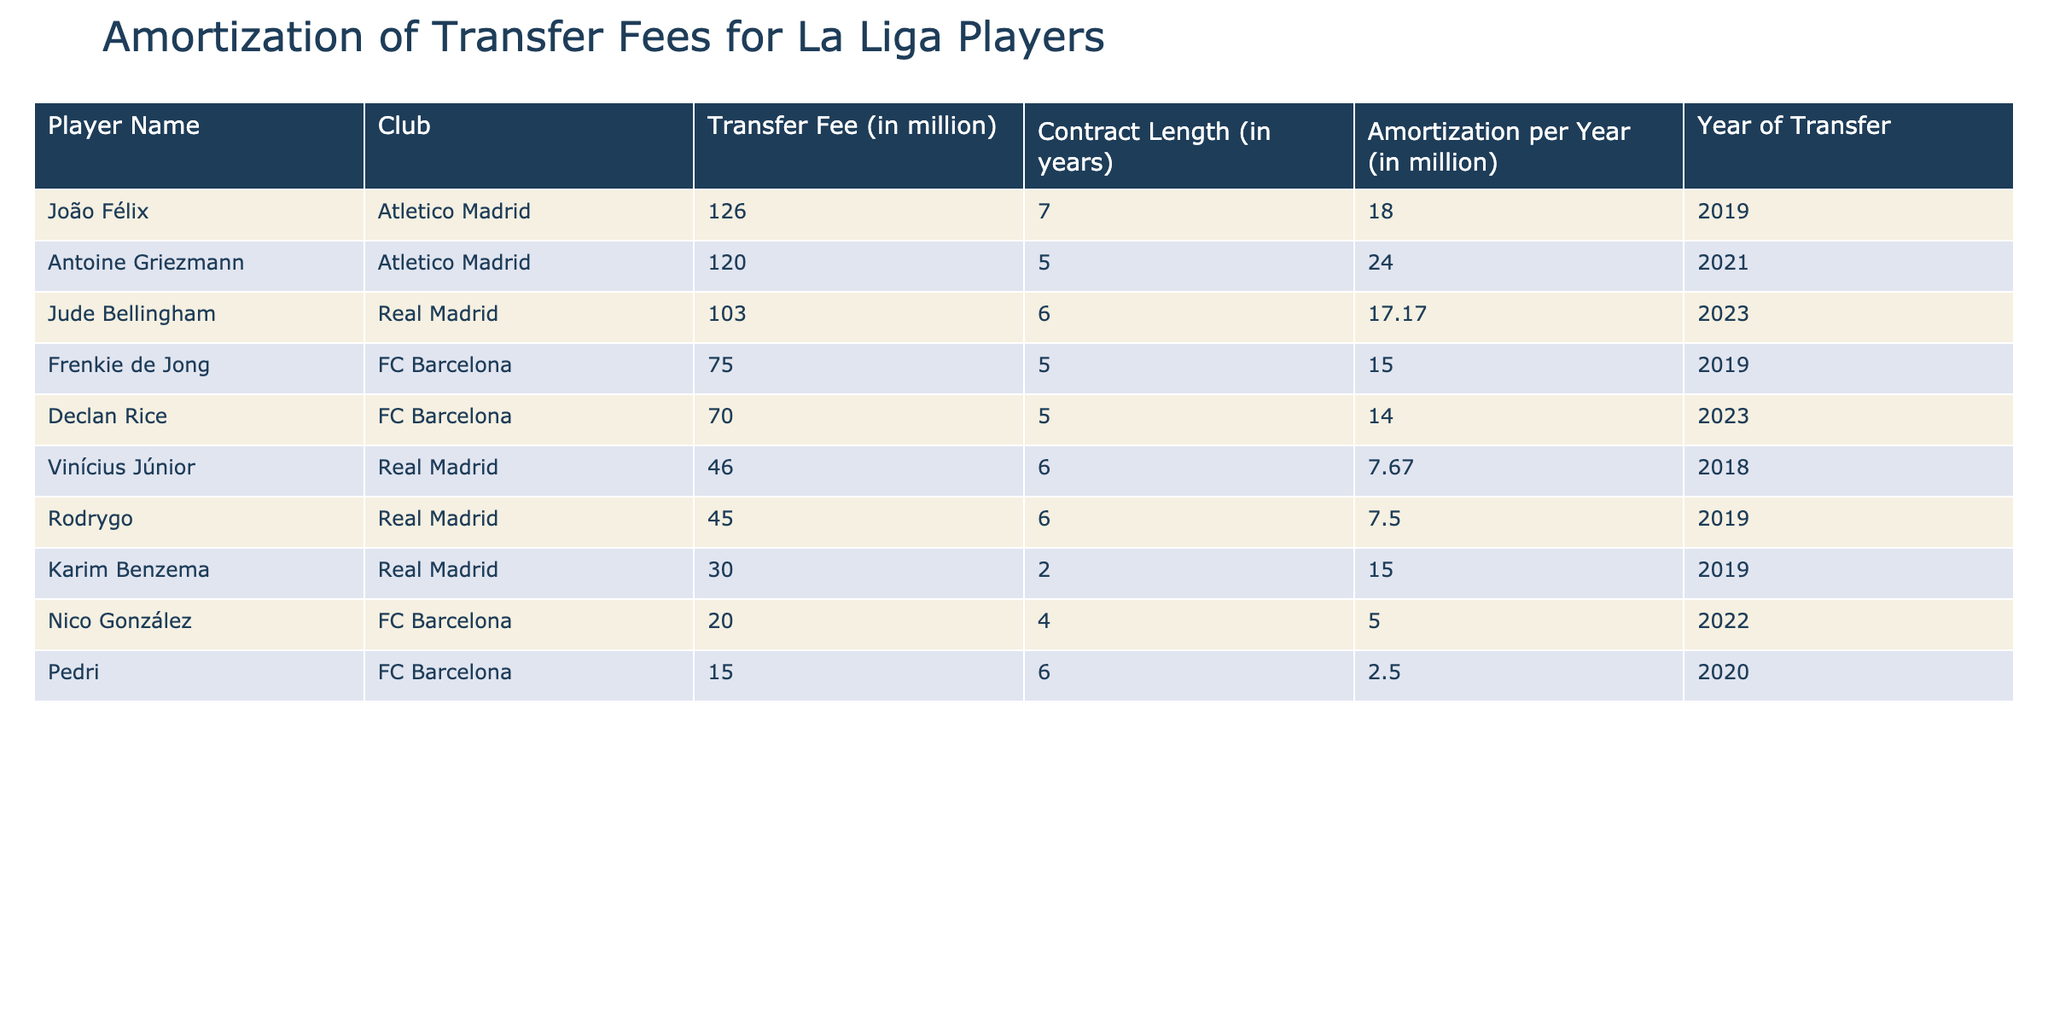What is the highest transfer fee recorded in the table? By looking at the 'Transfer Fee (in million)' column, we can see that the highest fee is associated with Antoine Griezmann, where the fee is 120 million.
Answer: 120 million Which player has the longest contract length? The 'Contract Length (in years)' column shows that João Félix has a contract length of 7 years, which is the longest compared to other players in the table.
Answer: 7 years What is the total amortization amount for players from Real Madrid? We need to sum the 'Amortization per Year (in million)' values for players like Jude Bellingham, Rodrygo, and Vinícius Júnior. The total is 17.17 + 7.50 + 7.67 = 32.34 million.
Answer: 32.34 million Is the amortization per year for Declan Rice higher than that for Frenkie de Jong? By comparing the 'Amortization per Year (in million)' values, Declan Rice has 14.00 million and Frenkie de Jong has 15.00 million. Declan Rice's amortization is lower.
Answer: No What is the average amortization for players in FC Barcelona? To find the average, we will look at the players from FC Barcelona: Declan Rice (14.00), Frenkie de Jong (15.00), Pedri (2.50), and Nico González (5.00). The total is 36.50 million, and there are 4 players, so the average is 36.50 / 4 = 9.125 million.
Answer: 9.125 million Who has a lower transfer fee, Rodrygo or Vinícius Júnior? Checking the 'Transfer Fee (in million)' for both players, Rodrygo has a fee of 45 million while Vinícius Júnior has a fee of 46 million. Therefore, Rodrygo has the lower transfer fee.
Answer: Rodrygo What is the difference in amortization between João Félix and Antoine Griezmann? To find the difference, we look at their amortization amounts: João Félix has 18.00 million and Antoine Griezmann has 24.00 million. The difference is 24.00 - 18.00 = 6.00 million.
Answer: 6.00 million Do all players from Real Madrid have an amortization value higher than 7 million? The players from Real Madrid are Jude Bellingham (17.17), Rodrygo (7.50), and Vinícius Júnior (7.67). The value for Rodrygo is exactly 7.50 million, which is higher, but not strictly greater.
Answer: No What is the sum of transfer fees for players with contracts longer than 5 years? The players with longer contracts are João Félix (126 million), Jude Bellingham (103 million), and Rodrygo (45 million); João Félix has a 7-year contract while the others have 6 years. Adding these gives us 126 + 103 + 45 = 274 million.
Answer: 274 million 